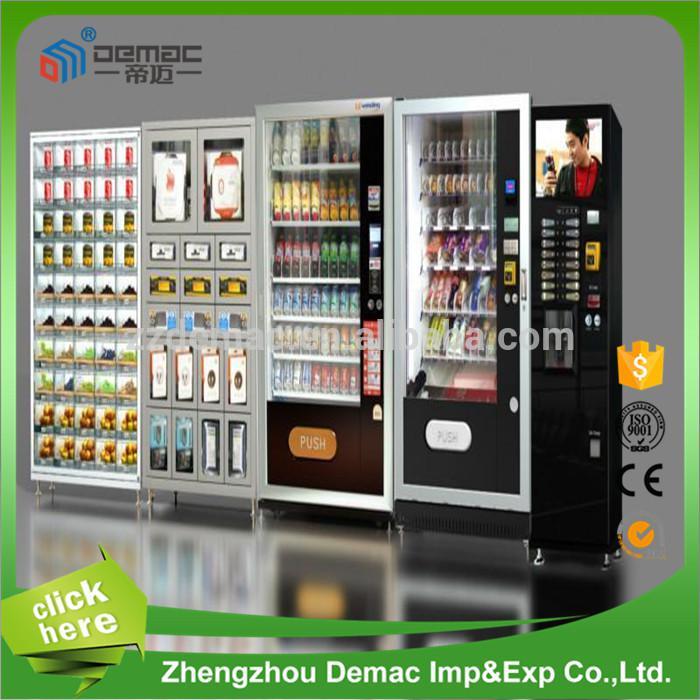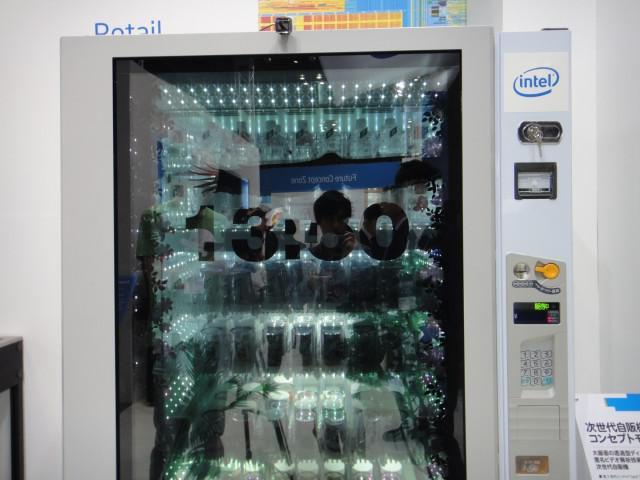The first image is the image on the left, the second image is the image on the right. For the images shown, is this caption "Neither image has an actual human being that is standing up." true? Answer yes or no. Yes. The first image is the image on the left, the second image is the image on the right. Analyze the images presented: Is the assertion "Somewhere in one image, a back-turned person stands in front of a lit screen of some type." valid? Answer yes or no. No. 